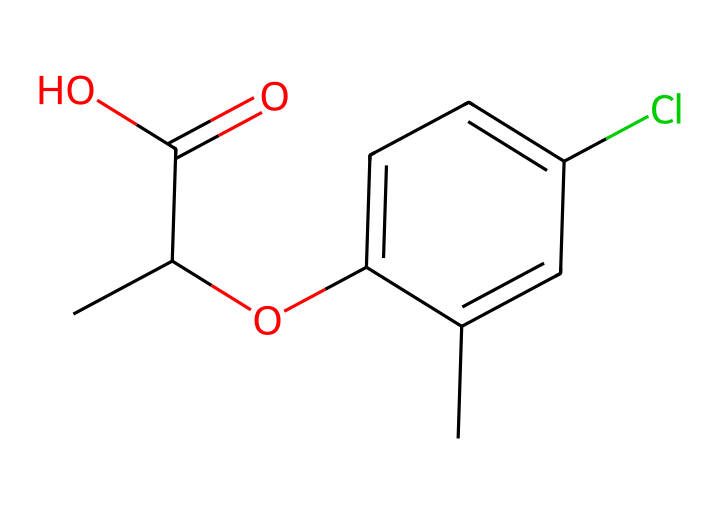What is the name of the chemical represented by the SMILES? The SMILES representation corresponds to mecoprop; this can be determined by translating the SMILES to its chemical structure and identifying it through chemical databases.
Answer: mecoprop How many carbon atoms are present in mecoprop? The structure can be analyzed to count the number of carbon atoms, which are denoted in the SMILES. In this case, there are 10 carbon atoms visible from the structure.
Answer: 10 How many chlorine atoms are present in the structure? The SMILES includes the 'Cl' notation indicating the presence of one chlorine atom attached to a carbon atom in the aromatic ring of the chemical structure.
Answer: 1 What functional group is present in mecoprop? The structure features a carboxylic acid group (–COOH), identifiable by the presence of a carbonyl (C=O) and a hydroxyl (–OH) attached to the carbon, deduced from the 'C(=O)O' part of the SMILES.
Answer: carboxylic acid What type of herbicide is mecoprop classified as? Understanding the structure and the presence of the specific functional groups suggests that mecoprop is phenoxy herbicide, commonly used to control broadleaf weeds.
Answer: phenoxy herbicide Which category of substances does mecoprop fall under based on its usage? Since mecoprop is utilized for weed control, particularly in maintaining green spaces, it is classified under herbicides used in lawn and turf care.
Answer: herbicides What is the significance of the aromatic ring in the chemical's properties? The presence of the aromatic ring contributes to the stability of the molecule and influences its interaction with biochemical pathways in plants, essential for herbicidal activity.
Answer: stability and activity 